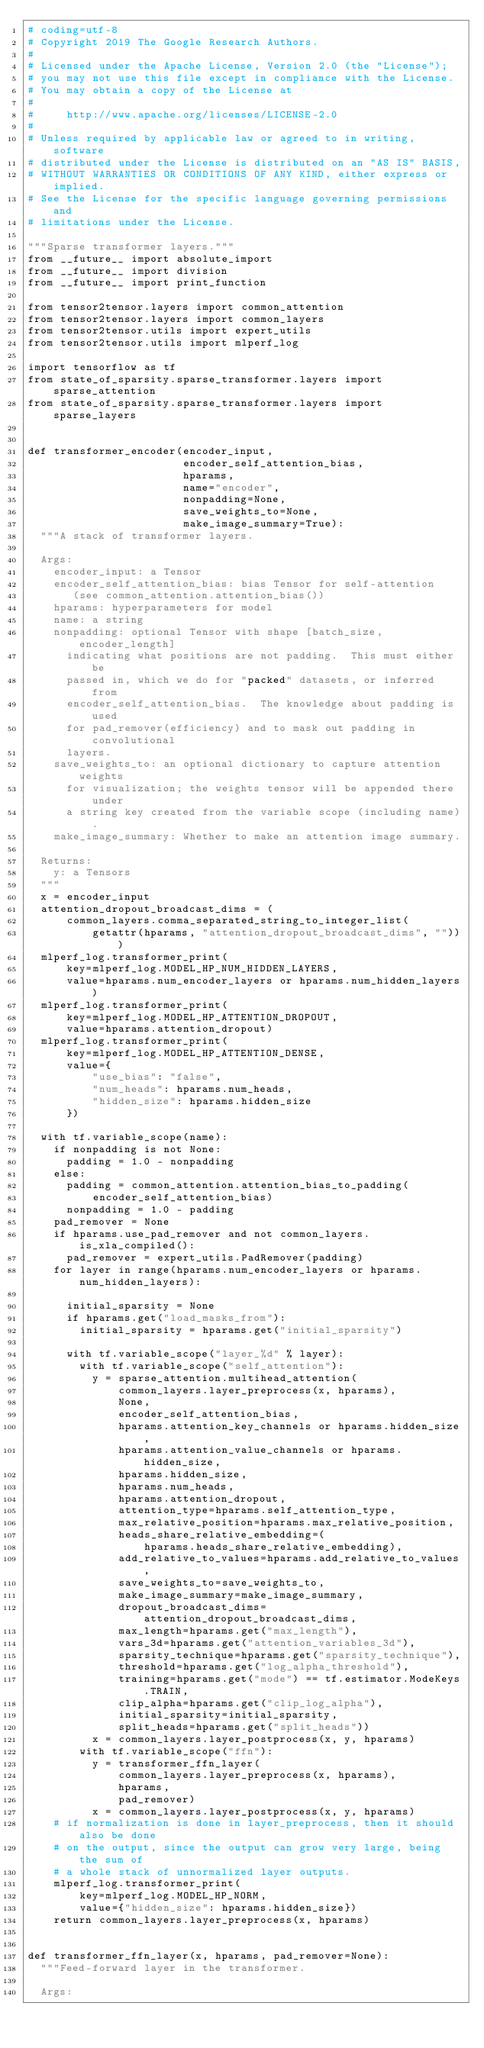Convert code to text. <code><loc_0><loc_0><loc_500><loc_500><_Python_># coding=utf-8
# Copyright 2019 The Google Research Authors.
#
# Licensed under the Apache License, Version 2.0 (the "License");
# you may not use this file except in compliance with the License.
# You may obtain a copy of the License at
#
#     http://www.apache.org/licenses/LICENSE-2.0
#
# Unless required by applicable law or agreed to in writing, software
# distributed under the License is distributed on an "AS IS" BASIS,
# WITHOUT WARRANTIES OR CONDITIONS OF ANY KIND, either express or implied.
# See the License for the specific language governing permissions and
# limitations under the License.

"""Sparse transformer layers."""
from __future__ import absolute_import
from __future__ import division
from __future__ import print_function

from tensor2tensor.layers import common_attention
from tensor2tensor.layers import common_layers
from tensor2tensor.utils import expert_utils
from tensor2tensor.utils import mlperf_log

import tensorflow as tf
from state_of_sparsity.sparse_transformer.layers import sparse_attention
from state_of_sparsity.sparse_transformer.layers import sparse_layers


def transformer_encoder(encoder_input,
                        encoder_self_attention_bias,
                        hparams,
                        name="encoder",
                        nonpadding=None,
                        save_weights_to=None,
                        make_image_summary=True):
  """A stack of transformer layers.

  Args:
    encoder_input: a Tensor
    encoder_self_attention_bias: bias Tensor for self-attention
       (see common_attention.attention_bias())
    hparams: hyperparameters for model
    name: a string
    nonpadding: optional Tensor with shape [batch_size, encoder_length]
      indicating what positions are not padding.  This must either be
      passed in, which we do for "packed" datasets, or inferred from
      encoder_self_attention_bias.  The knowledge about padding is used
      for pad_remover(efficiency) and to mask out padding in convolutional
      layers.
    save_weights_to: an optional dictionary to capture attention weights
      for visualization; the weights tensor will be appended there under
      a string key created from the variable scope (including name).
    make_image_summary: Whether to make an attention image summary.

  Returns:
    y: a Tensors
  """
  x = encoder_input
  attention_dropout_broadcast_dims = (
      common_layers.comma_separated_string_to_integer_list(
          getattr(hparams, "attention_dropout_broadcast_dims", "")))
  mlperf_log.transformer_print(
      key=mlperf_log.MODEL_HP_NUM_HIDDEN_LAYERS,
      value=hparams.num_encoder_layers or hparams.num_hidden_layers)
  mlperf_log.transformer_print(
      key=mlperf_log.MODEL_HP_ATTENTION_DROPOUT,
      value=hparams.attention_dropout)
  mlperf_log.transformer_print(
      key=mlperf_log.MODEL_HP_ATTENTION_DENSE,
      value={
          "use_bias": "false",
          "num_heads": hparams.num_heads,
          "hidden_size": hparams.hidden_size
      })

  with tf.variable_scope(name):
    if nonpadding is not None:
      padding = 1.0 - nonpadding
    else:
      padding = common_attention.attention_bias_to_padding(
          encoder_self_attention_bias)
      nonpadding = 1.0 - padding
    pad_remover = None
    if hparams.use_pad_remover and not common_layers.is_xla_compiled():
      pad_remover = expert_utils.PadRemover(padding)
    for layer in range(hparams.num_encoder_layers or hparams.num_hidden_layers):

      initial_sparsity = None
      if hparams.get("load_masks_from"):
        initial_sparsity = hparams.get("initial_sparsity")

      with tf.variable_scope("layer_%d" % layer):
        with tf.variable_scope("self_attention"):
          y = sparse_attention.multihead_attention(
              common_layers.layer_preprocess(x, hparams),
              None,
              encoder_self_attention_bias,
              hparams.attention_key_channels or hparams.hidden_size,
              hparams.attention_value_channels or hparams.hidden_size,
              hparams.hidden_size,
              hparams.num_heads,
              hparams.attention_dropout,
              attention_type=hparams.self_attention_type,
              max_relative_position=hparams.max_relative_position,
              heads_share_relative_embedding=(
                  hparams.heads_share_relative_embedding),
              add_relative_to_values=hparams.add_relative_to_values,
              save_weights_to=save_weights_to,
              make_image_summary=make_image_summary,
              dropout_broadcast_dims=attention_dropout_broadcast_dims,
              max_length=hparams.get("max_length"),
              vars_3d=hparams.get("attention_variables_3d"),
              sparsity_technique=hparams.get("sparsity_technique"),
              threshold=hparams.get("log_alpha_threshold"),
              training=hparams.get("mode") == tf.estimator.ModeKeys.TRAIN,
              clip_alpha=hparams.get("clip_log_alpha"),
              initial_sparsity=initial_sparsity,
              split_heads=hparams.get("split_heads"))
          x = common_layers.layer_postprocess(x, y, hparams)
        with tf.variable_scope("ffn"):
          y = transformer_ffn_layer(
              common_layers.layer_preprocess(x, hparams),
              hparams,
              pad_remover)
          x = common_layers.layer_postprocess(x, y, hparams)
    # if normalization is done in layer_preprocess, then it should also be done
    # on the output, since the output can grow very large, being the sum of
    # a whole stack of unnormalized layer outputs.
    mlperf_log.transformer_print(
        key=mlperf_log.MODEL_HP_NORM,
        value={"hidden_size": hparams.hidden_size})
    return common_layers.layer_preprocess(x, hparams)


def transformer_ffn_layer(x, hparams, pad_remover=None):
  """Feed-forward layer in the transformer.

  Args:</code> 